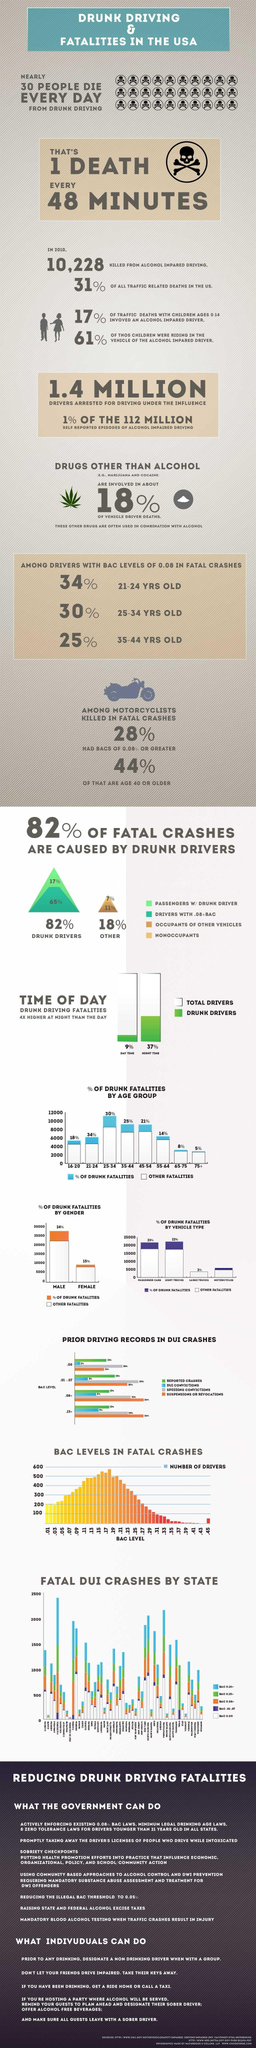Indicate a few pertinent items in this graphic. According to a recent study, 17% of fatal crashes were caused by drunk drivers who were accompanying passengers. According to data, in the United States, males have the highest percentage of drunk fatalities out of any gender. Approximately 15% of drunk fatalities in the United States are caused by females. In the United States, during the daytime, approximately 9% of fatal car accidents are caused by drunk driving. In 2010, a total of 10,228 individuals in the United States were killed as a result of alcohol-impaired driving. 